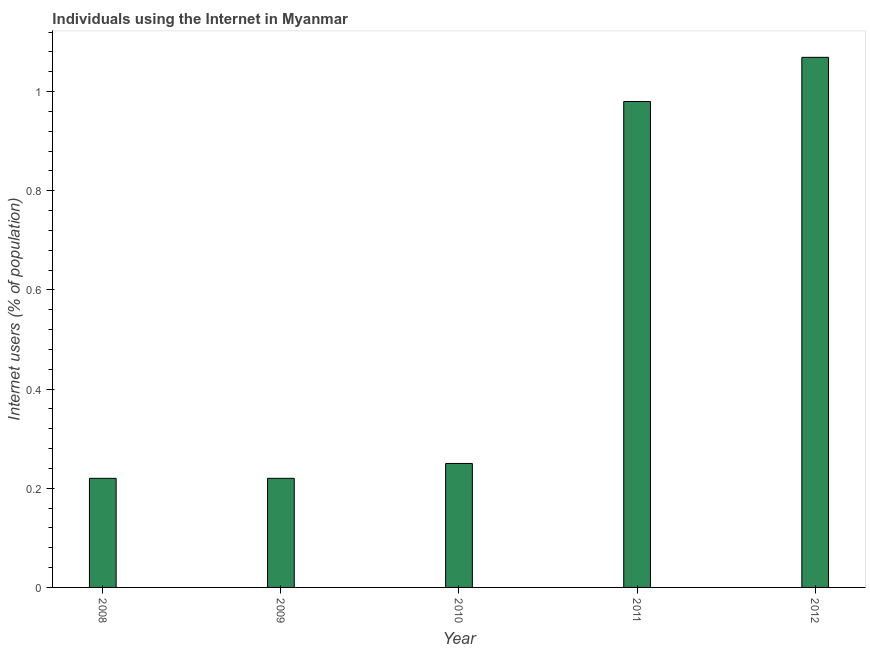Does the graph contain any zero values?
Your answer should be very brief. No. Does the graph contain grids?
Your answer should be compact. No. What is the title of the graph?
Provide a short and direct response. Individuals using the Internet in Myanmar. What is the label or title of the X-axis?
Make the answer very short. Year. What is the label or title of the Y-axis?
Make the answer very short. Internet users (% of population). What is the number of internet users in 2009?
Give a very brief answer. 0.22. Across all years, what is the maximum number of internet users?
Give a very brief answer. 1.07. Across all years, what is the minimum number of internet users?
Give a very brief answer. 0.22. In which year was the number of internet users minimum?
Offer a terse response. 2008. What is the sum of the number of internet users?
Offer a terse response. 2.74. What is the difference between the number of internet users in 2010 and 2012?
Your answer should be compact. -0.82. What is the average number of internet users per year?
Ensure brevity in your answer.  0.55. What is the ratio of the number of internet users in 2009 to that in 2011?
Provide a short and direct response. 0.22. Is the difference between the number of internet users in 2011 and 2012 greater than the difference between any two years?
Provide a succinct answer. No. What is the difference between the highest and the second highest number of internet users?
Your answer should be compact. 0.09. In how many years, is the number of internet users greater than the average number of internet users taken over all years?
Provide a short and direct response. 2. Are the values on the major ticks of Y-axis written in scientific E-notation?
Provide a short and direct response. No. What is the Internet users (% of population) of 2008?
Give a very brief answer. 0.22. What is the Internet users (% of population) of 2009?
Your answer should be very brief. 0.22. What is the Internet users (% of population) of 2012?
Keep it short and to the point. 1.07. What is the difference between the Internet users (% of population) in 2008 and 2009?
Offer a terse response. 0. What is the difference between the Internet users (% of population) in 2008 and 2010?
Keep it short and to the point. -0.03. What is the difference between the Internet users (% of population) in 2008 and 2011?
Make the answer very short. -0.76. What is the difference between the Internet users (% of population) in 2008 and 2012?
Offer a terse response. -0.85. What is the difference between the Internet users (% of population) in 2009 and 2010?
Keep it short and to the point. -0.03. What is the difference between the Internet users (% of population) in 2009 and 2011?
Provide a succinct answer. -0.76. What is the difference between the Internet users (% of population) in 2009 and 2012?
Provide a succinct answer. -0.85. What is the difference between the Internet users (% of population) in 2010 and 2011?
Keep it short and to the point. -0.73. What is the difference between the Internet users (% of population) in 2010 and 2012?
Provide a succinct answer. -0.82. What is the difference between the Internet users (% of population) in 2011 and 2012?
Offer a terse response. -0.09. What is the ratio of the Internet users (% of population) in 2008 to that in 2009?
Your answer should be very brief. 1. What is the ratio of the Internet users (% of population) in 2008 to that in 2010?
Give a very brief answer. 0.88. What is the ratio of the Internet users (% of population) in 2008 to that in 2011?
Your response must be concise. 0.22. What is the ratio of the Internet users (% of population) in 2008 to that in 2012?
Offer a terse response. 0.21. What is the ratio of the Internet users (% of population) in 2009 to that in 2011?
Make the answer very short. 0.22. What is the ratio of the Internet users (% of population) in 2009 to that in 2012?
Provide a short and direct response. 0.21. What is the ratio of the Internet users (% of population) in 2010 to that in 2011?
Provide a succinct answer. 0.26. What is the ratio of the Internet users (% of population) in 2010 to that in 2012?
Your answer should be compact. 0.23. What is the ratio of the Internet users (% of population) in 2011 to that in 2012?
Provide a short and direct response. 0.92. 